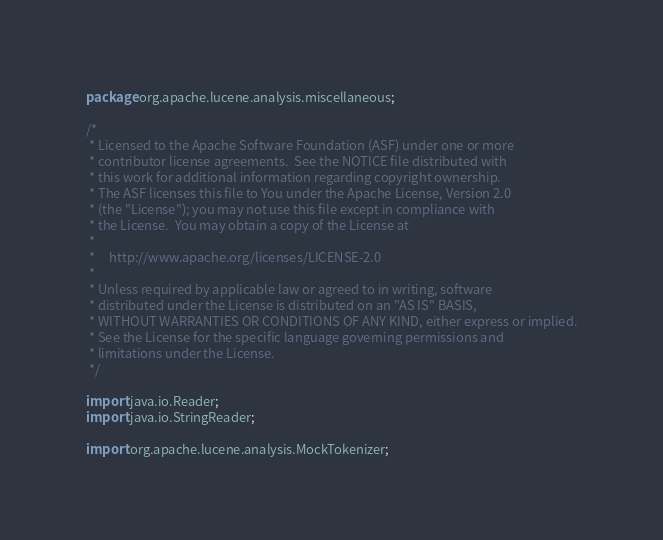<code> <loc_0><loc_0><loc_500><loc_500><_Java_>package org.apache.lucene.analysis.miscellaneous;

/*
 * Licensed to the Apache Software Foundation (ASF) under one or more
 * contributor license agreements.  See the NOTICE file distributed with
 * this work for additional information regarding copyright ownership.
 * The ASF licenses this file to You under the Apache License, Version 2.0
 * (the "License"); you may not use this file except in compliance with
 * the License.  You may obtain a copy of the License at
 *
 *     http://www.apache.org/licenses/LICENSE-2.0
 *
 * Unless required by applicable law or agreed to in writing, software
 * distributed under the License is distributed on an "AS IS" BASIS,
 * WITHOUT WARRANTIES OR CONDITIONS OF ANY KIND, either express or implied.
 * See the License for the specific language governing permissions and
 * limitations under the License.
 */

import java.io.Reader;
import java.io.StringReader;

import org.apache.lucene.analysis.MockTokenizer;</code> 